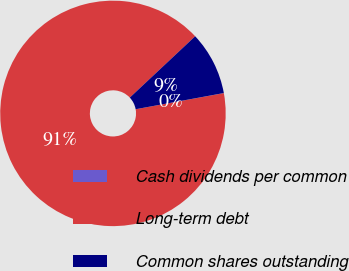Convert chart. <chart><loc_0><loc_0><loc_500><loc_500><pie_chart><fcel>Cash dividends per common<fcel>Long-term debt<fcel>Common shares outstanding<nl><fcel>0.01%<fcel>90.89%<fcel>9.1%<nl></chart> 